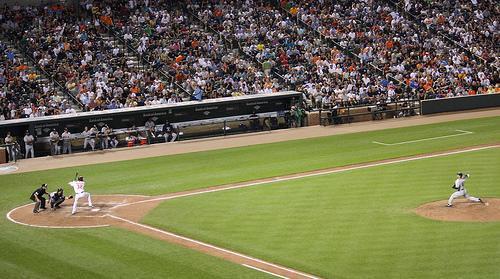How many people are seen on the playing field?
Give a very brief answer. 4. 